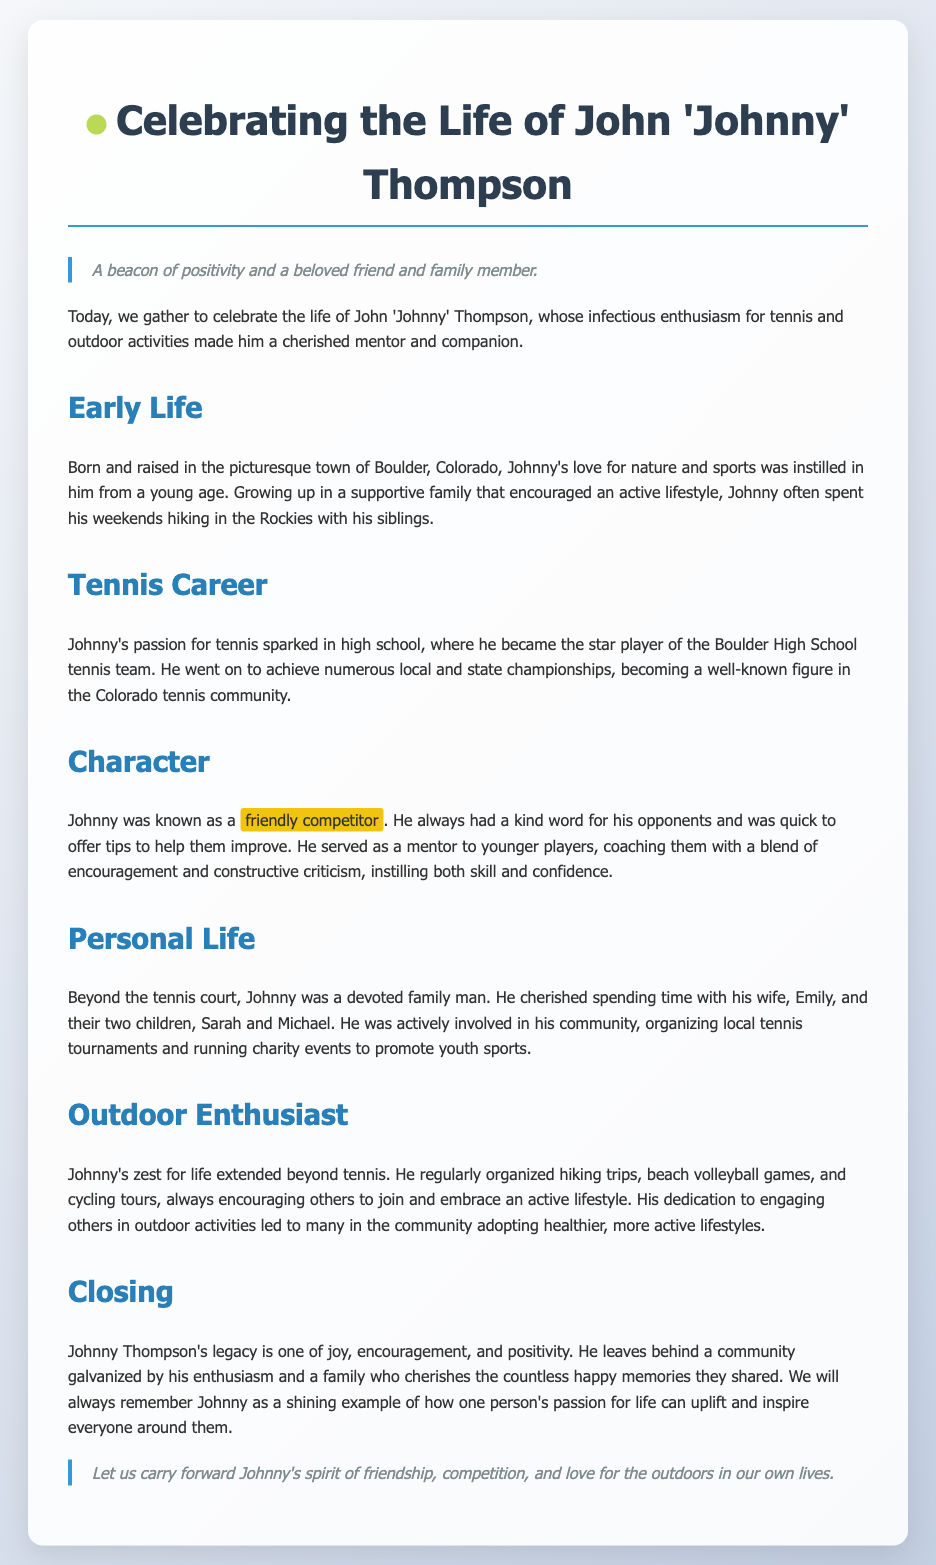What was Johnny Thompson's profession? Johnny Thompson was known for his involvement in tennis as a player and mentor in the community.
Answer: Tennis Where was Johnny born? The document states that he was born and raised in Boulder, Colorado.
Answer: Boulder, Colorado How many children did Johnny have? The text mentions Johnny had two children, Sarah and Michael.
Answer: Two What was one of Johnny's main traits as a competitor? The document highlights Johnny as a "friendly competitor," indicating his supportive nature.
Answer: Friendly competitor What activities did Johnny organize beyond tennis? The text lists hiking trips, beach volleyball games, and cycling tours as activities he organized.
Answer: Hiking, beach volleyball, cycling What did Johnny's legacy promote in the community? Johnny's legacy galvanized the community towards adopting healthier, more active lifestyles.
Answer: Healthy lifestyles Who was Johnny's wife? The document mentions that Johnny was a devoted family man and his wife's name was Emily.
Answer: Emily What was the primary theme of the eulogy? The eulogy focuses on Johnny’s joy, encouragement, and positivity.
Answer: Joy, encouragement, positivity What did Johnny instill in younger players? He instilled both skill and confidence in younger players through his mentoring.
Answer: Skills and confidence 